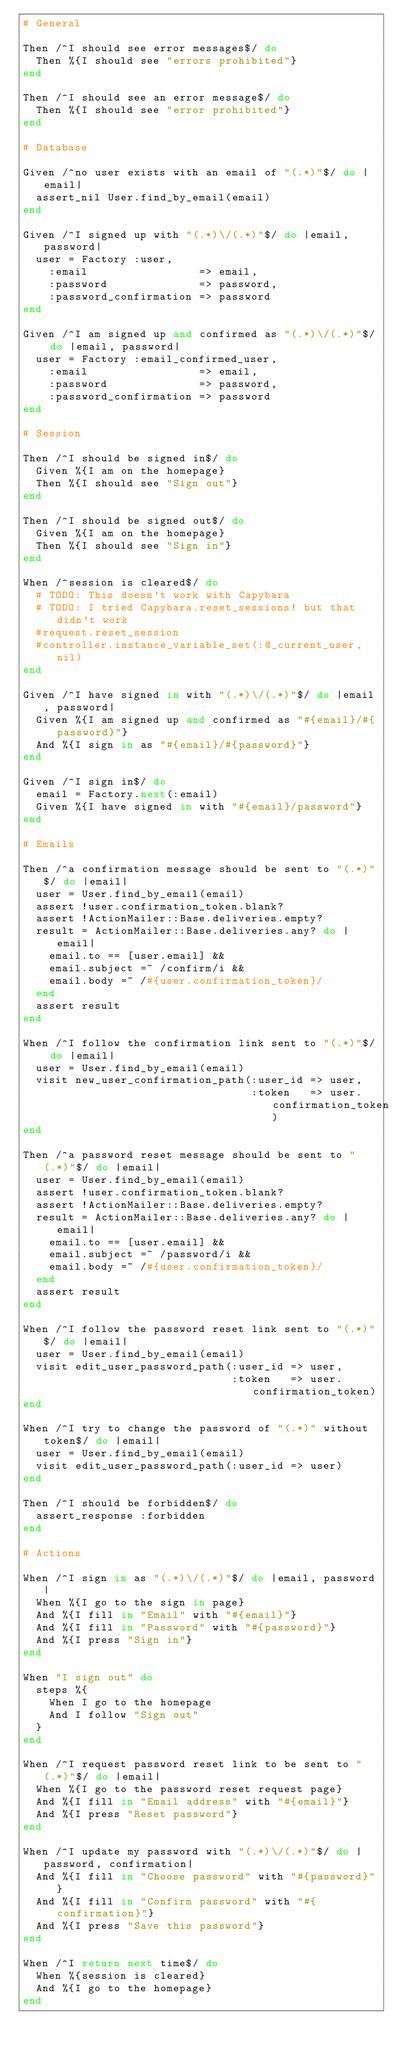Convert code to text. <code><loc_0><loc_0><loc_500><loc_500><_Ruby_># General

Then /^I should see error messages$/ do
  Then %{I should see "errors prohibited"}
end

Then /^I should see an error message$/ do
  Then %{I should see "error prohibited"}
end

# Database

Given /^no user exists with an email of "(.*)"$/ do |email|
  assert_nil User.find_by_email(email)
end

Given /^I signed up with "(.*)\/(.*)"$/ do |email, password|
  user = Factory :user,
    :email                 => email,
    :password              => password,
    :password_confirmation => password
end

Given /^I am signed up and confirmed as "(.*)\/(.*)"$/ do |email, password|
  user = Factory :email_confirmed_user,
    :email                 => email,
    :password              => password,
    :password_confirmation => password
end

# Session

Then /^I should be signed in$/ do
  Given %{I am on the homepage}
  Then %{I should see "Sign out"}
end

Then /^I should be signed out$/ do
  Given %{I am on the homepage}
  Then %{I should see "Sign in"}
end

When /^session is cleared$/ do
  # TODO: This doesn't work with Capybara
  # TODO: I tried Capybara.reset_sessions! but that didn't work
  #request.reset_session
  #controller.instance_variable_set(:@_current_user, nil)
end

Given /^I have signed in with "(.*)\/(.*)"$/ do |email, password|
  Given %{I am signed up and confirmed as "#{email}/#{password}"}
  And %{I sign in as "#{email}/#{password}"}
end

Given /^I sign in$/ do
  email = Factory.next(:email)
  Given %{I have signed in with "#{email}/password"}
end

# Emails

Then /^a confirmation message should be sent to "(.*)"$/ do |email|
  user = User.find_by_email(email)
  assert !user.confirmation_token.blank?
  assert !ActionMailer::Base.deliveries.empty?
  result = ActionMailer::Base.deliveries.any? do |email|
    email.to == [user.email] &&
    email.subject =~ /confirm/i &&
    email.body =~ /#{user.confirmation_token}/
  end
  assert result
end

When /^I follow the confirmation link sent to "(.*)"$/ do |email|
  user = User.find_by_email(email)
  visit new_user_confirmation_path(:user_id => user,
                                   :token   => user.confirmation_token)
end

Then /^a password reset message should be sent to "(.*)"$/ do |email|
  user = User.find_by_email(email)
  assert !user.confirmation_token.blank?
  assert !ActionMailer::Base.deliveries.empty?
  result = ActionMailer::Base.deliveries.any? do |email|
    email.to == [user.email] &&
    email.subject =~ /password/i &&
    email.body =~ /#{user.confirmation_token}/
  end
  assert result
end

When /^I follow the password reset link sent to "(.*)"$/ do |email|
  user = User.find_by_email(email)
  visit edit_user_password_path(:user_id => user,
                                :token   => user.confirmation_token)
end

When /^I try to change the password of "(.*)" without token$/ do |email|
  user = User.find_by_email(email)
  visit edit_user_password_path(:user_id => user)
end

Then /^I should be forbidden$/ do
  assert_response :forbidden
end

# Actions

When /^I sign in as "(.*)\/(.*)"$/ do |email, password|
  When %{I go to the sign in page}
  And %{I fill in "Email" with "#{email}"}
  And %{I fill in "Password" with "#{password}"}
  And %{I press "Sign in"}
end

When "I sign out" do
  steps %{
    When I go to the homepage
    And I follow "Sign out"
  }
end

When /^I request password reset link to be sent to "(.*)"$/ do |email|
  When %{I go to the password reset request page}
  And %{I fill in "Email address" with "#{email}"}
  And %{I press "Reset password"}
end

When /^I update my password with "(.*)\/(.*)"$/ do |password, confirmation|
  And %{I fill in "Choose password" with "#{password}"}
  And %{I fill in "Confirm password" with "#{confirmation}"}
  And %{I press "Save this password"}
end

When /^I return next time$/ do
  When %{session is cleared}
  And %{I go to the homepage}
end
</code> 